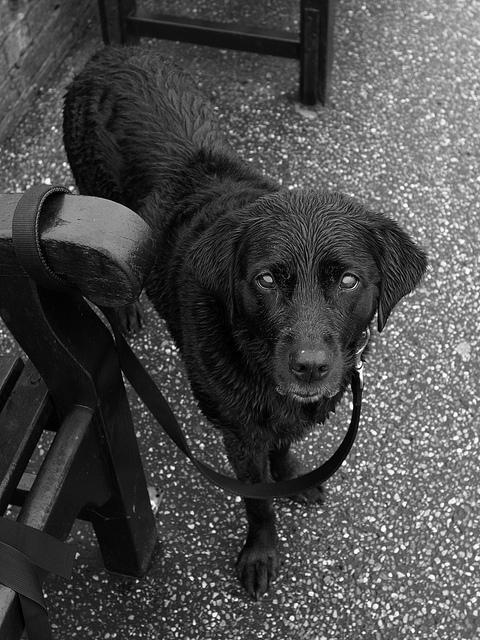How many benches are there?
Give a very brief answer. 2. How many people are not wearing glasses?
Give a very brief answer. 0. 